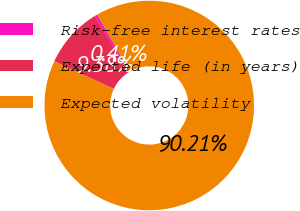Convert chart. <chart><loc_0><loc_0><loc_500><loc_500><pie_chart><fcel>Risk-free interest rates<fcel>Expected life (in years)<fcel>Expected volatility<nl><fcel>0.41%<fcel>9.38%<fcel>90.21%<nl></chart> 